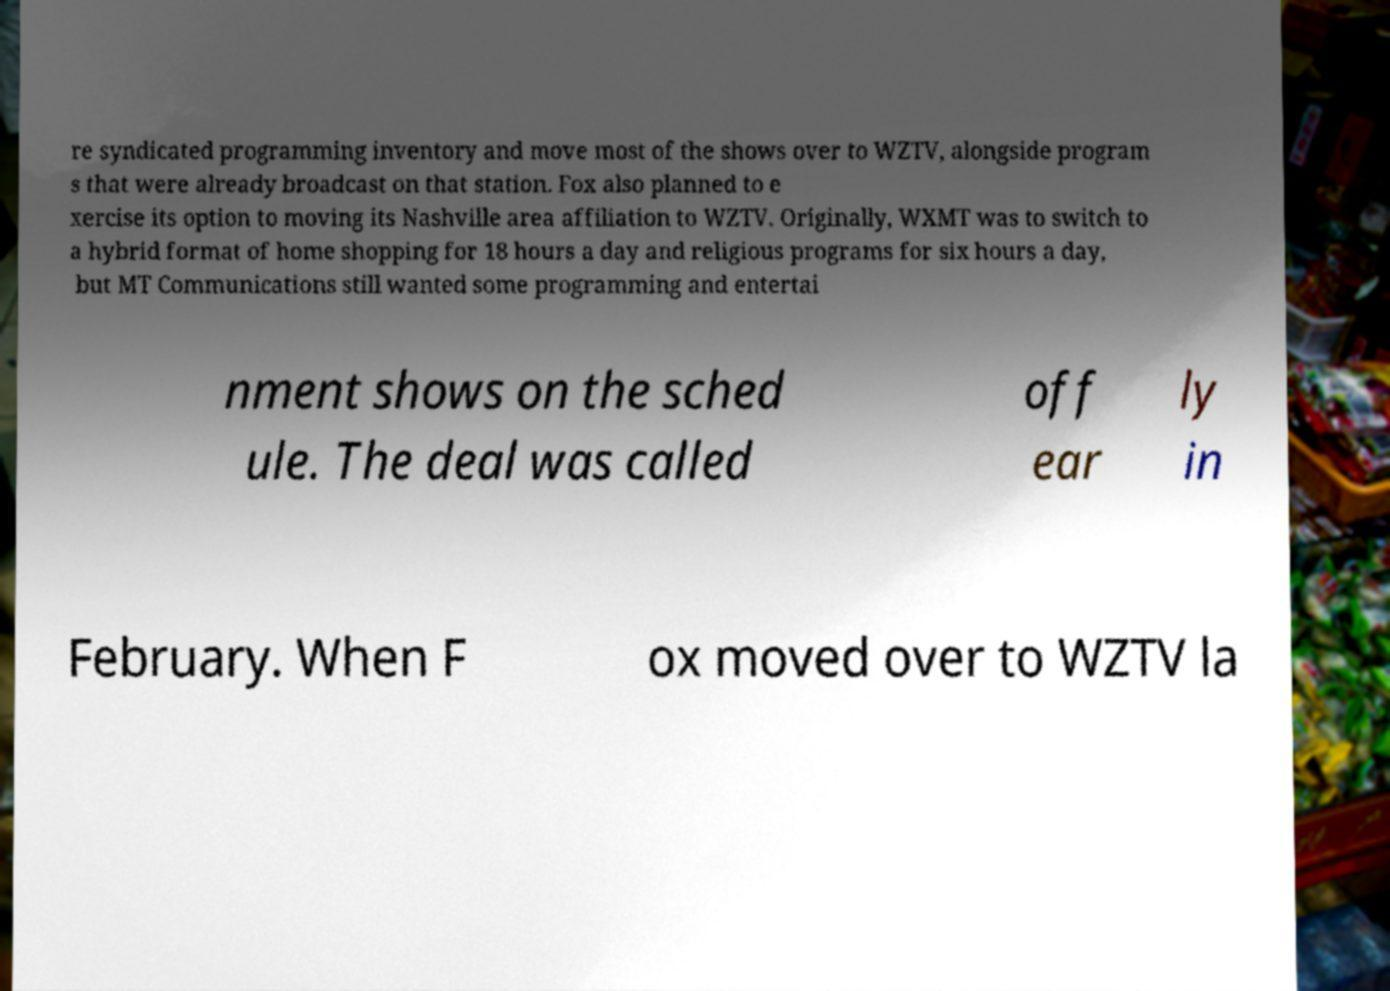Can you accurately transcribe the text from the provided image for me? re syndicated programming inventory and move most of the shows over to WZTV, alongside program s that were already broadcast on that station. Fox also planned to e xercise its option to moving its Nashville area affiliation to WZTV. Originally, WXMT was to switch to a hybrid format of home shopping for 18 hours a day and religious programs for six hours a day, but MT Communications still wanted some programming and entertai nment shows on the sched ule. The deal was called off ear ly in February. When F ox moved over to WZTV la 